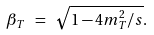Convert formula to latex. <formula><loc_0><loc_0><loc_500><loc_500>\beta _ { T } \ = \ \sqrt { 1 - 4 m _ { T } ^ { 2 } / s } .</formula> 